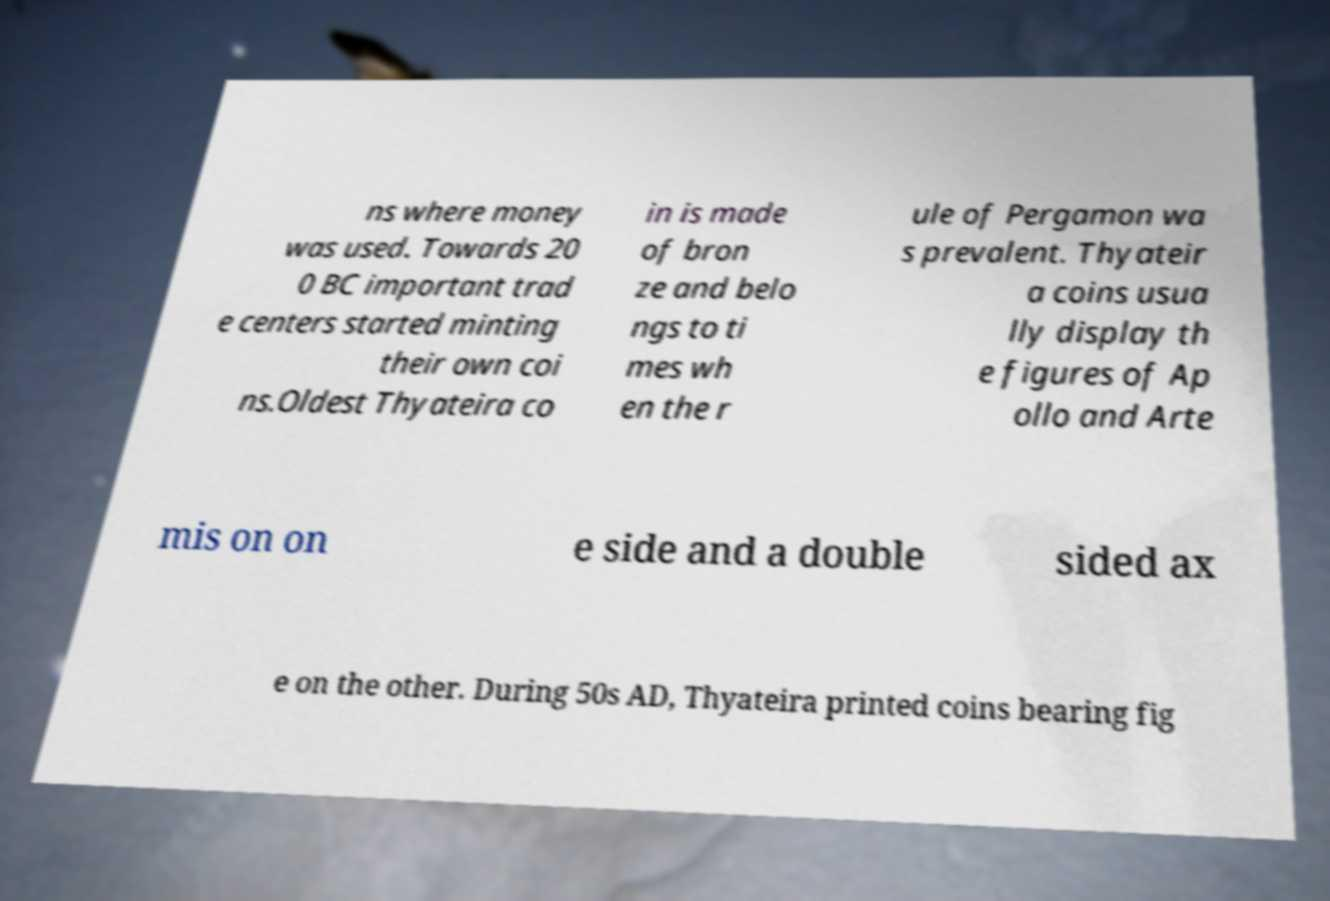What messages or text are displayed in this image? I need them in a readable, typed format. ns where money was used. Towards 20 0 BC important trad e centers started minting their own coi ns.Oldest Thyateira co in is made of bron ze and belo ngs to ti mes wh en the r ule of Pergamon wa s prevalent. Thyateir a coins usua lly display th e figures of Ap ollo and Arte mis on on e side and a double sided ax e on the other. During 50s AD, Thyateira printed coins bearing fig 